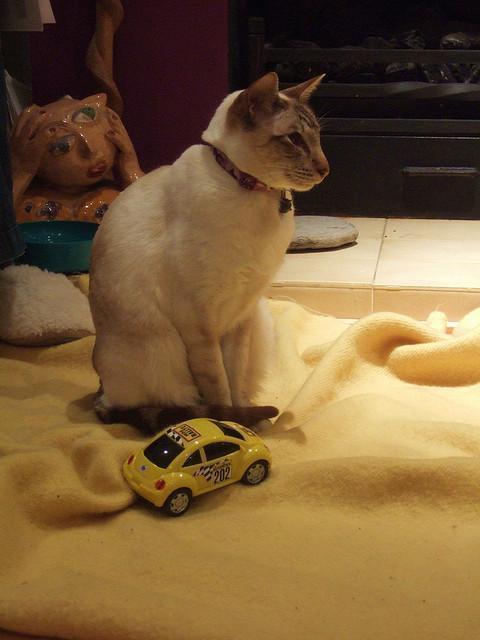What room is it?
Select the accurate response from the four choices given to answer the question.
Options: Bedroom, kitchen, dining room, family room. Family room. 